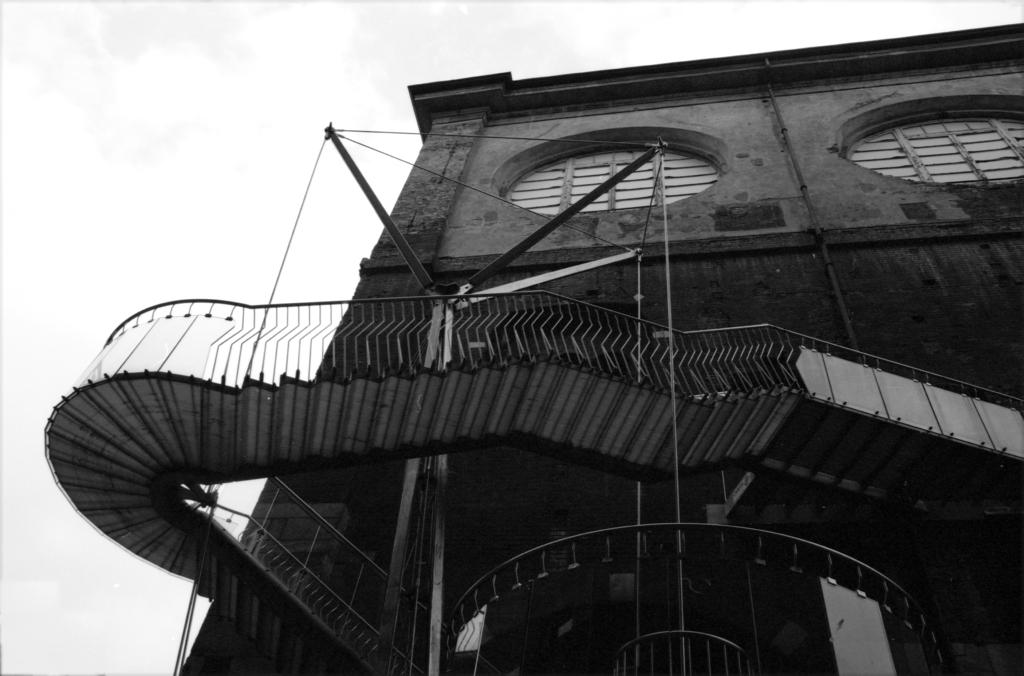What type of structure is present in the image? There are stairs in the image. What feature is associated with the stairs? There is a metal railing associated with the stairs. What can be seen in the background of the image? There is a building visible in the image. What architectural elements are present on the building? There are windows on the building. What other object can be seen in the image? There is a pipeline in the image. What is visible at the top of the image? The sky is visible at the top of the image. What type of show is being requested by the person in the image? There is no person present in the image, and therefore no show or request can be observed. 